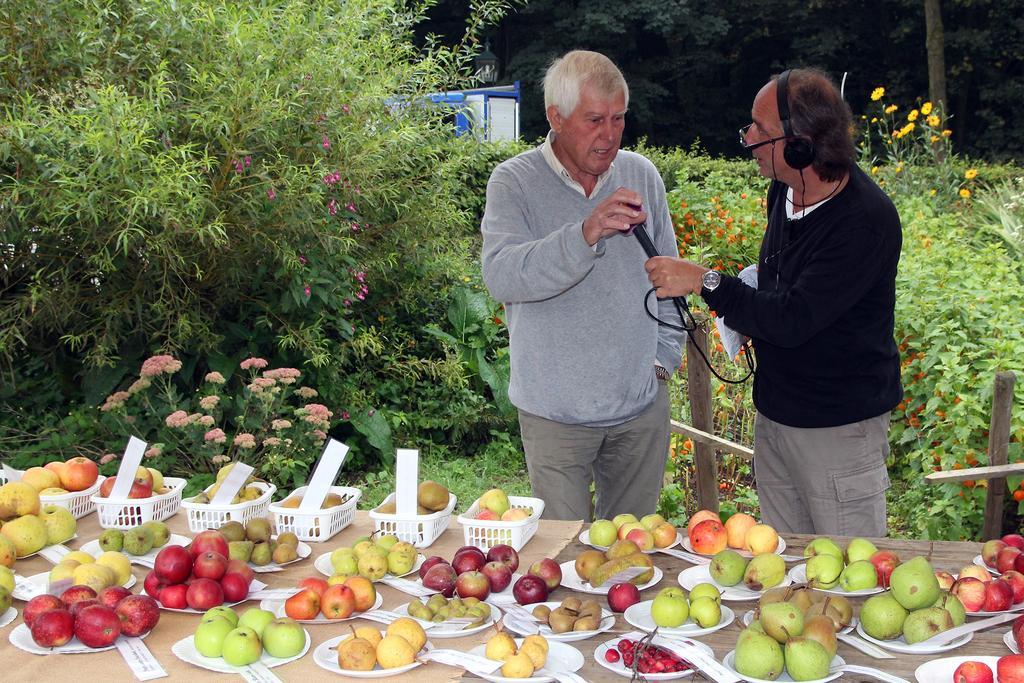In one or two sentences, can you explain what this image depicts? In this picture I can see a table in front, on which there are plates and baskets and I see fruits in it. In the background I can see the plants and few flowers and behind the table I can see 2 men standing and the man on the right is holding a mic. 